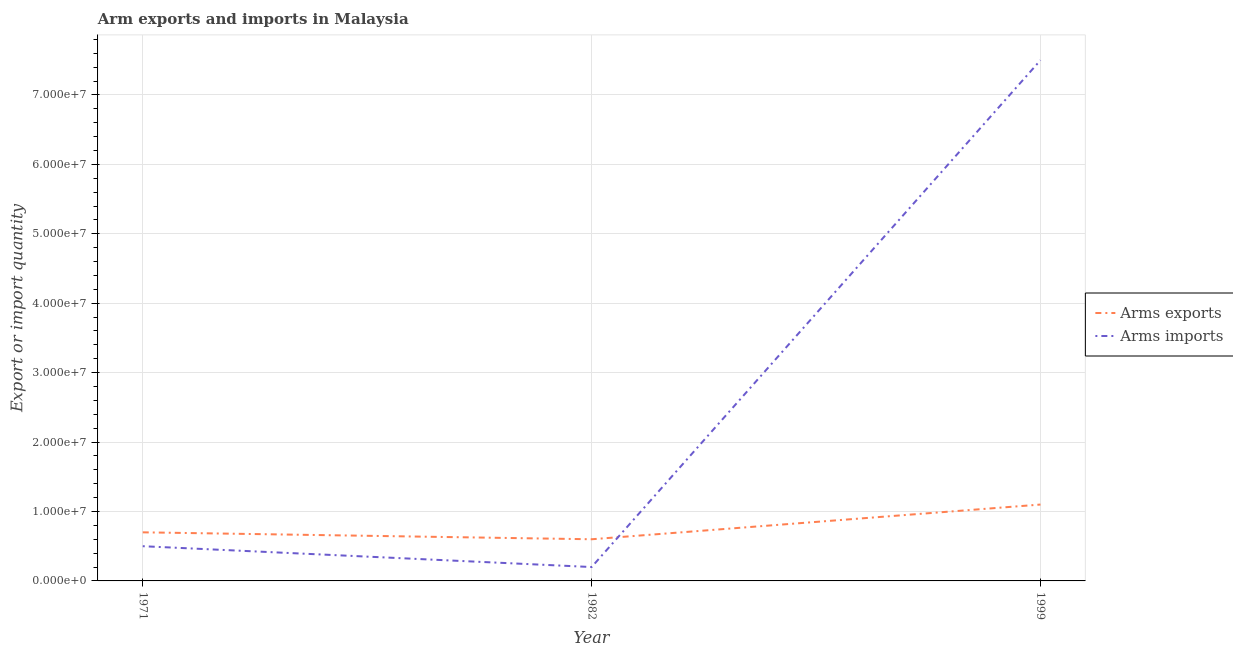Is the number of lines equal to the number of legend labels?
Offer a very short reply. Yes. What is the arms exports in 1971?
Offer a terse response. 7.00e+06. Across all years, what is the maximum arms imports?
Make the answer very short. 7.50e+07. Across all years, what is the minimum arms imports?
Offer a very short reply. 2.00e+06. In which year was the arms exports maximum?
Give a very brief answer. 1999. In which year was the arms imports minimum?
Provide a short and direct response. 1982. What is the total arms exports in the graph?
Keep it short and to the point. 2.40e+07. What is the difference between the arms exports in 1982 and that in 1999?
Make the answer very short. -5.00e+06. What is the difference between the arms exports in 1999 and the arms imports in 1971?
Your answer should be very brief. 6.00e+06. What is the average arms imports per year?
Keep it short and to the point. 2.73e+07. In the year 1999, what is the difference between the arms exports and arms imports?
Provide a short and direct response. -6.40e+07. In how many years, is the arms exports greater than 32000000?
Your response must be concise. 0. What is the ratio of the arms imports in 1982 to that in 1999?
Your answer should be very brief. 0.03. What is the difference between the highest and the lowest arms exports?
Make the answer very short. 5.00e+06. In how many years, is the arms exports greater than the average arms exports taken over all years?
Your response must be concise. 1. Does the arms imports monotonically increase over the years?
Ensure brevity in your answer.  No. Is the arms exports strictly greater than the arms imports over the years?
Provide a succinct answer. No. How many lines are there?
Provide a succinct answer. 2. Are the values on the major ticks of Y-axis written in scientific E-notation?
Provide a succinct answer. Yes. Where does the legend appear in the graph?
Your response must be concise. Center right. How are the legend labels stacked?
Offer a very short reply. Vertical. What is the title of the graph?
Your response must be concise. Arm exports and imports in Malaysia. Does "Under-five" appear as one of the legend labels in the graph?
Give a very brief answer. No. What is the label or title of the X-axis?
Offer a terse response. Year. What is the label or title of the Y-axis?
Your answer should be very brief. Export or import quantity. What is the Export or import quantity of Arms exports in 1971?
Provide a short and direct response. 7.00e+06. What is the Export or import quantity of Arms exports in 1982?
Provide a succinct answer. 6.00e+06. What is the Export or import quantity in Arms exports in 1999?
Provide a succinct answer. 1.10e+07. What is the Export or import quantity of Arms imports in 1999?
Keep it short and to the point. 7.50e+07. Across all years, what is the maximum Export or import quantity in Arms exports?
Your answer should be very brief. 1.10e+07. Across all years, what is the maximum Export or import quantity in Arms imports?
Give a very brief answer. 7.50e+07. Across all years, what is the minimum Export or import quantity of Arms exports?
Make the answer very short. 6.00e+06. What is the total Export or import quantity of Arms exports in the graph?
Keep it short and to the point. 2.40e+07. What is the total Export or import quantity of Arms imports in the graph?
Provide a succinct answer. 8.20e+07. What is the difference between the Export or import quantity of Arms imports in 1971 and that in 1982?
Provide a succinct answer. 3.00e+06. What is the difference between the Export or import quantity in Arms imports in 1971 and that in 1999?
Give a very brief answer. -7.00e+07. What is the difference between the Export or import quantity in Arms exports in 1982 and that in 1999?
Offer a very short reply. -5.00e+06. What is the difference between the Export or import quantity in Arms imports in 1982 and that in 1999?
Offer a terse response. -7.30e+07. What is the difference between the Export or import quantity of Arms exports in 1971 and the Export or import quantity of Arms imports in 1999?
Keep it short and to the point. -6.80e+07. What is the difference between the Export or import quantity in Arms exports in 1982 and the Export or import quantity in Arms imports in 1999?
Your response must be concise. -6.90e+07. What is the average Export or import quantity in Arms exports per year?
Offer a terse response. 8.00e+06. What is the average Export or import quantity in Arms imports per year?
Offer a very short reply. 2.73e+07. In the year 1971, what is the difference between the Export or import quantity in Arms exports and Export or import quantity in Arms imports?
Make the answer very short. 2.00e+06. In the year 1999, what is the difference between the Export or import quantity of Arms exports and Export or import quantity of Arms imports?
Provide a succinct answer. -6.40e+07. What is the ratio of the Export or import quantity of Arms exports in 1971 to that in 1982?
Give a very brief answer. 1.17. What is the ratio of the Export or import quantity of Arms exports in 1971 to that in 1999?
Your answer should be very brief. 0.64. What is the ratio of the Export or import quantity of Arms imports in 1971 to that in 1999?
Give a very brief answer. 0.07. What is the ratio of the Export or import quantity of Arms exports in 1982 to that in 1999?
Your answer should be very brief. 0.55. What is the ratio of the Export or import quantity in Arms imports in 1982 to that in 1999?
Ensure brevity in your answer.  0.03. What is the difference between the highest and the second highest Export or import quantity in Arms exports?
Your answer should be compact. 4.00e+06. What is the difference between the highest and the second highest Export or import quantity of Arms imports?
Offer a terse response. 7.00e+07. What is the difference between the highest and the lowest Export or import quantity in Arms imports?
Offer a terse response. 7.30e+07. 